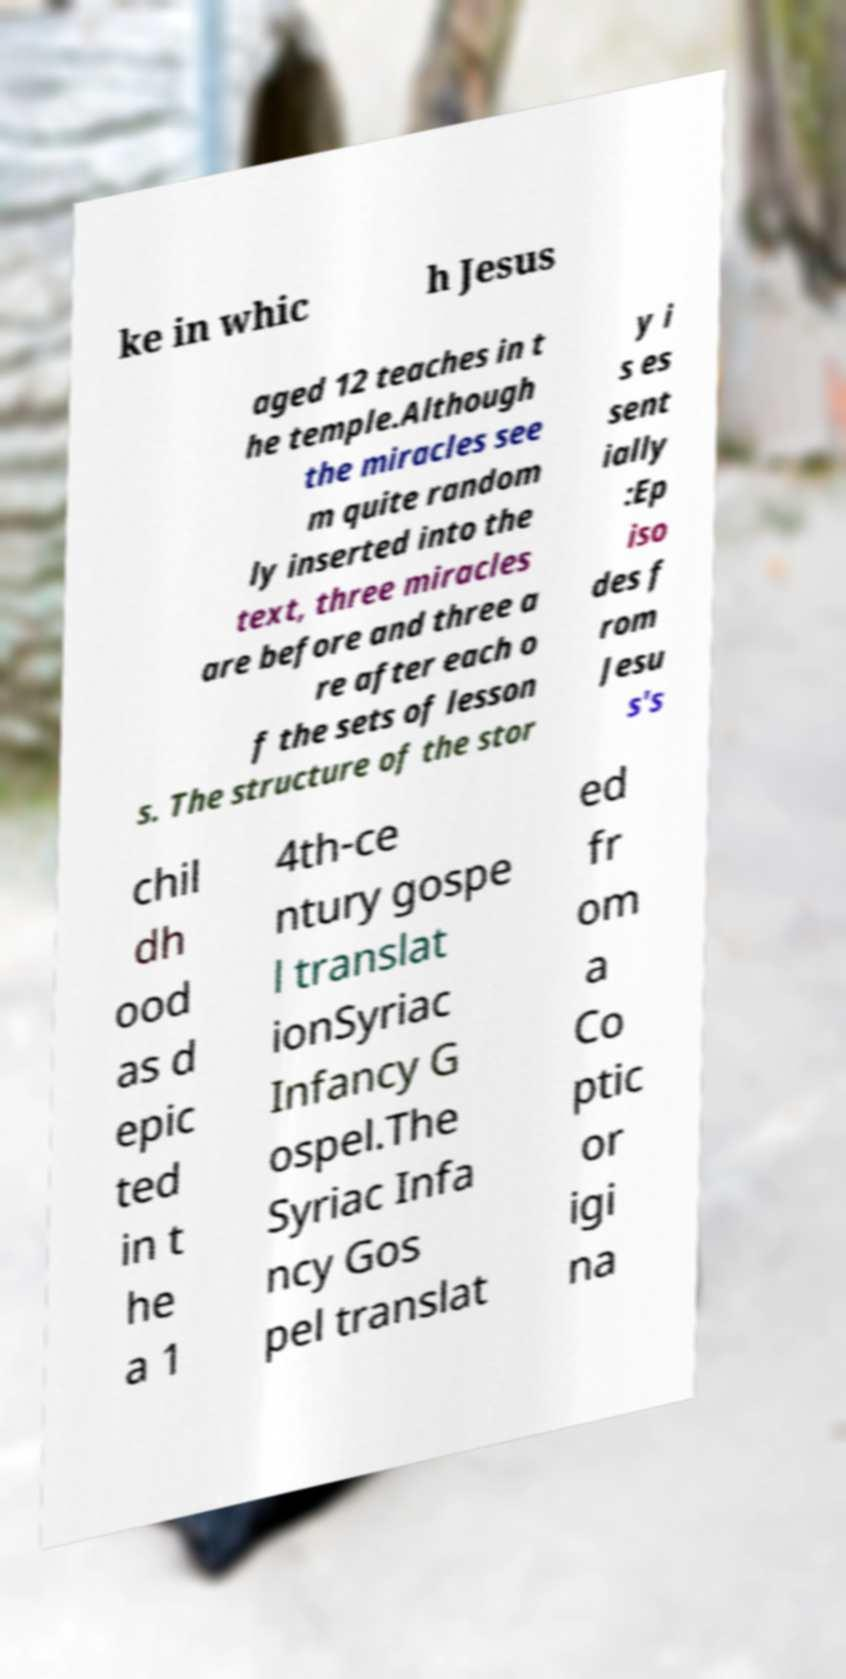Please read and relay the text visible in this image. What does it say? ke in whic h Jesus aged 12 teaches in t he temple.Although the miracles see m quite random ly inserted into the text, three miracles are before and three a re after each o f the sets of lesson s. The structure of the stor y i s es sent ially :Ep iso des f rom Jesu s's chil dh ood as d epic ted in t he a 1 4th-ce ntury gospe l translat ionSyriac Infancy G ospel.The Syriac Infa ncy Gos pel translat ed fr om a Co ptic or igi na 